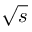<formula> <loc_0><loc_0><loc_500><loc_500>\sqrt { s }</formula> 